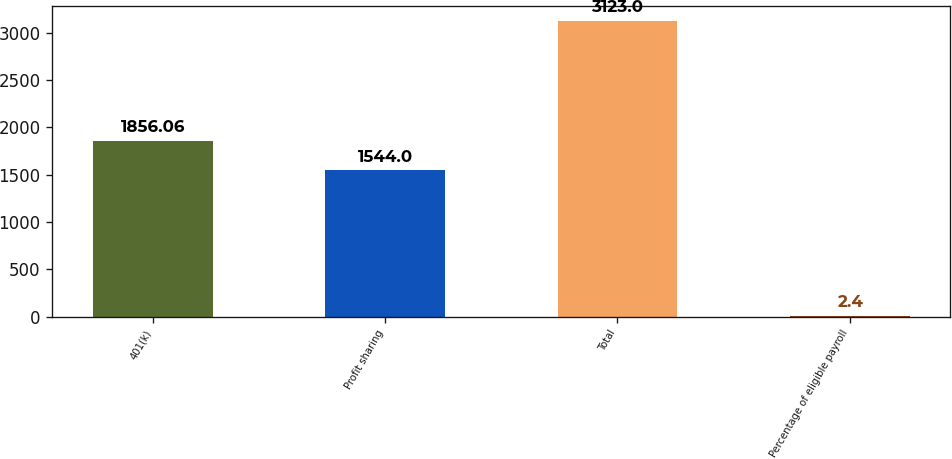Convert chart to OTSL. <chart><loc_0><loc_0><loc_500><loc_500><bar_chart><fcel>401(k)<fcel>Profit sharing<fcel>Total<fcel>Percentage of eligible payroll<nl><fcel>1856.06<fcel>1544<fcel>3123<fcel>2.4<nl></chart> 